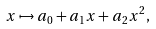<formula> <loc_0><loc_0><loc_500><loc_500>x \mapsto a _ { 0 } + a _ { 1 } x + a _ { 2 } x ^ { 2 } ,</formula> 